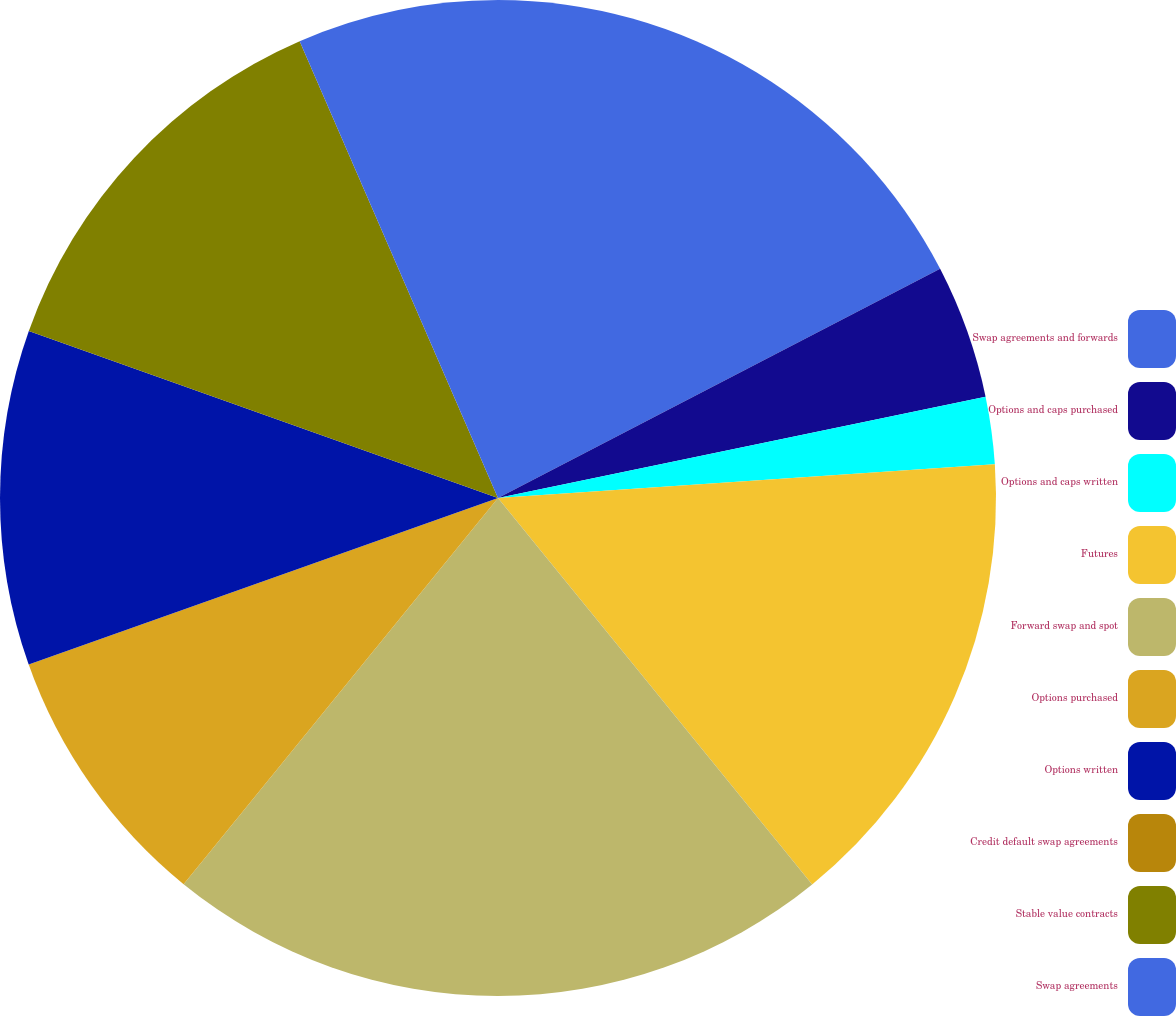<chart> <loc_0><loc_0><loc_500><loc_500><pie_chart><fcel>Swap agreements and forwards<fcel>Options and caps purchased<fcel>Options and caps written<fcel>Futures<fcel>Forward swap and spot<fcel>Options purchased<fcel>Options written<fcel>Credit default swap agreements<fcel>Stable value contracts<fcel>Swap agreements<nl><fcel>17.39%<fcel>4.35%<fcel>2.18%<fcel>15.22%<fcel>21.74%<fcel>8.7%<fcel>10.87%<fcel>0.0%<fcel>13.04%<fcel>6.52%<nl></chart> 